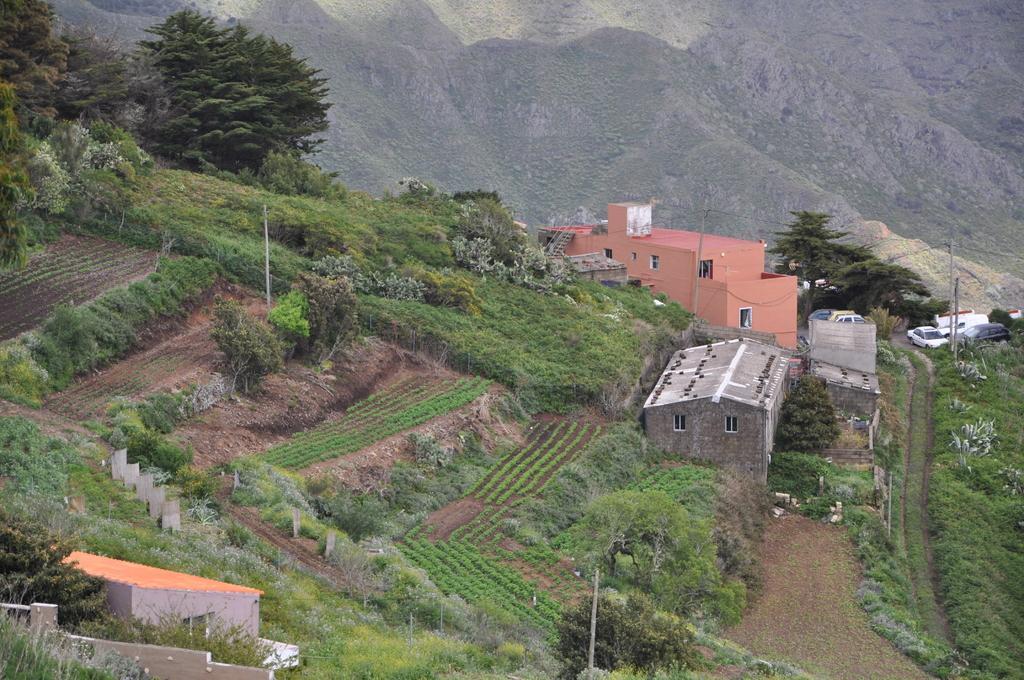Can you describe this image briefly? In the picture I can see the houses and trees. I can see the vehicles parked on the road on the right side. In the background, I can see the hills. 